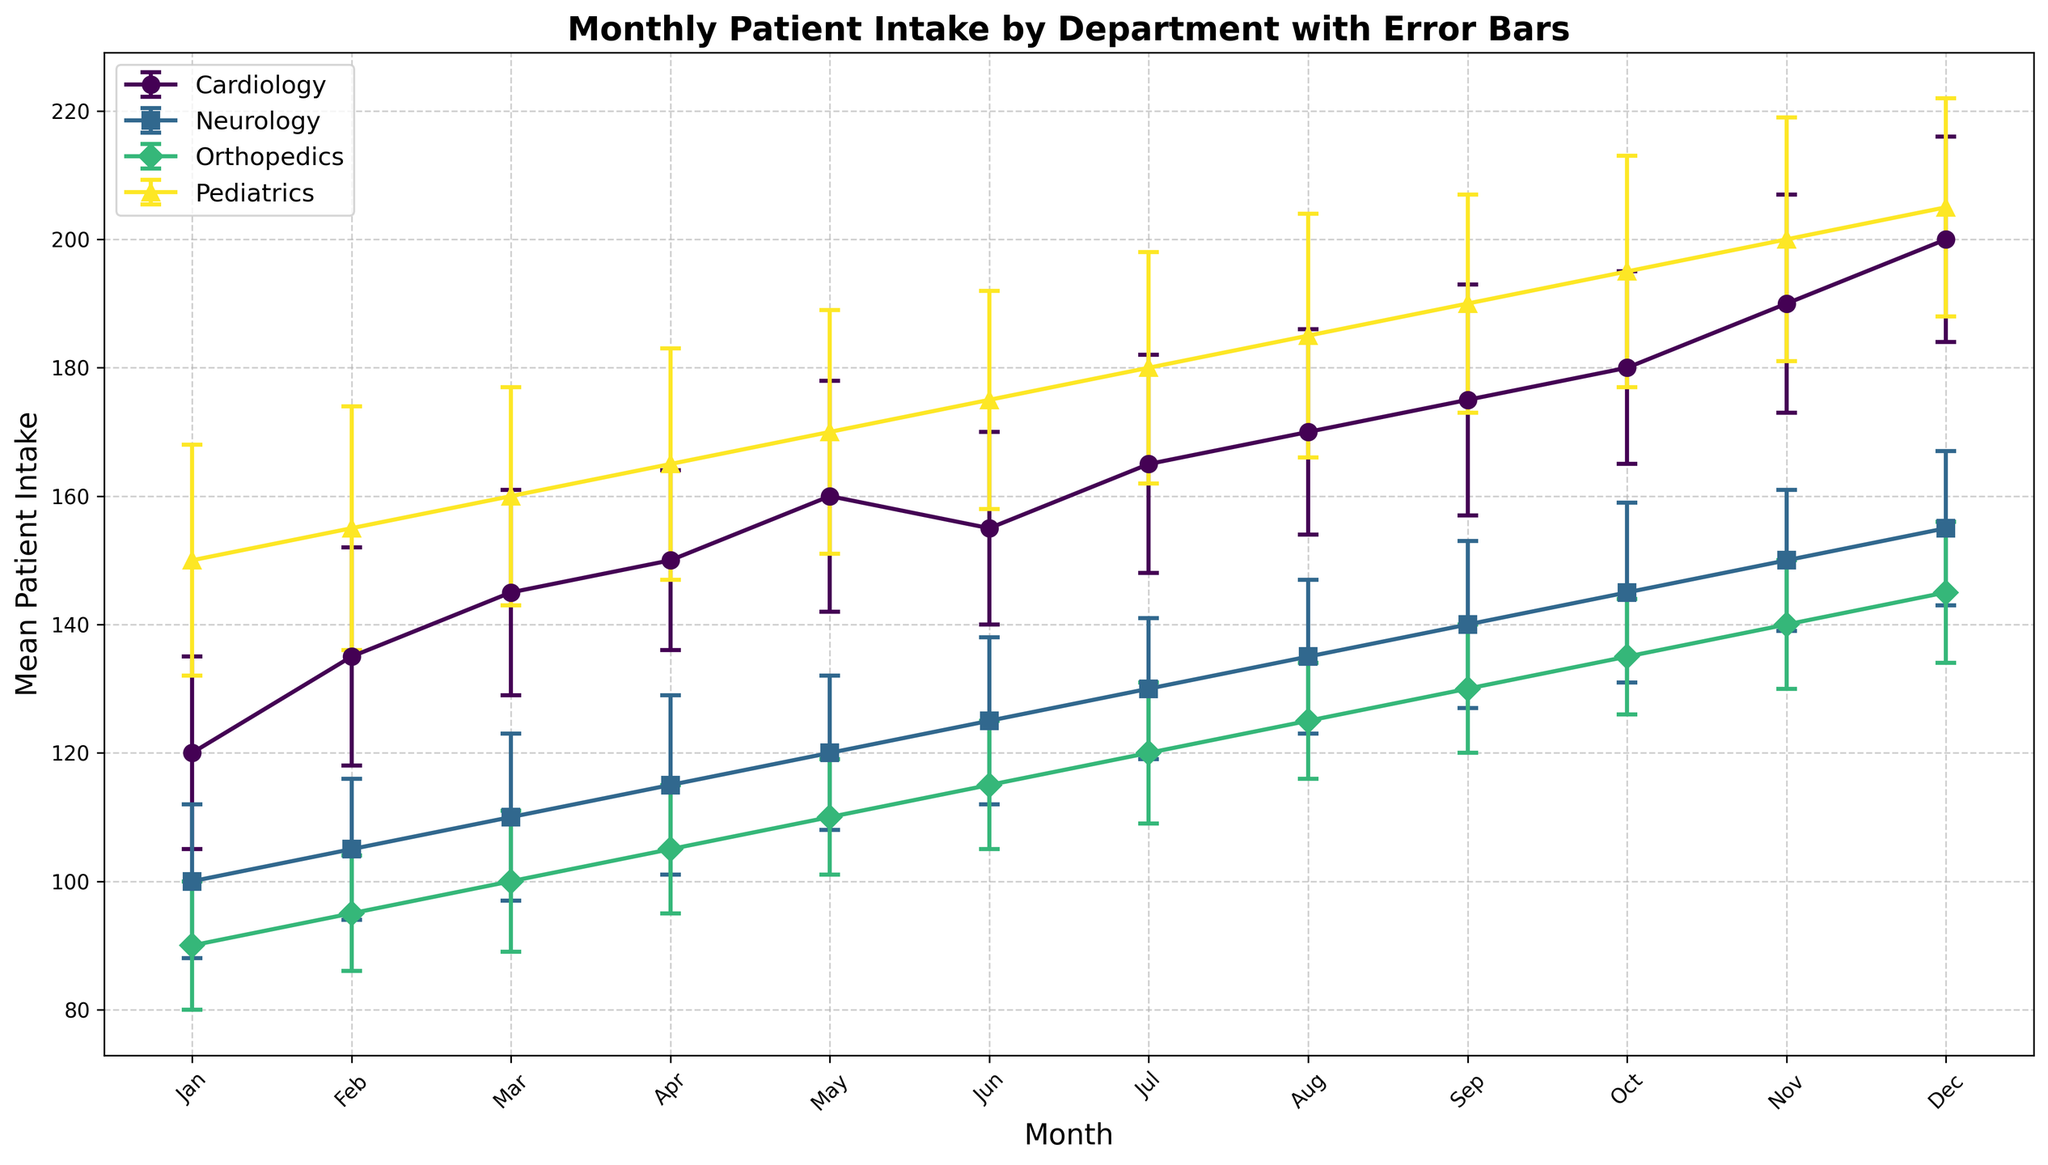What is the mean patient intake for Cardiology in June? The line for Cardiology shows the marker at June at a vertical position around 155, matching the table value.
Answer: 155 Which department had the highest mean patient intake in December? Review the December values on the plot. Pediatrics has the highest marker position, around 205.
Answer: Pediatrics What is the average mean patient intake for Neurology across all months? Sum the means for Neurology and divide by 12: (100+105+110+115+120+125+130+135+140+145+150+155)/12 = 126.25
Answer: 126.25 Which two departments had the closest mean patient intake in April, and what are their values? Compare April markers for each department. Orthopedics (105) and Neurology (115) are closest.
Answer: Orthopedics (105) and Neurology (115) How much higher is the mean patient intake for Pediatrics in March compared to Orthopedics in March? Look at March values for Pediatrics (160) and Orthopedics (100), then subtract: 160 - 100 = 60
Answer: 60 Which department tends to have the highest variability in patient intake? Examine error bars for all departments; Pediatrics consistently has the largest error bars.
Answer: Pediatrics How does the mean patient intake change from January to December for Neurology? Check the markers for Neurology from January (100) to December (155): December mean is higher by 55.
Answer: Increases by 55 What is the total mean patient intake across all departments for October? Sum October values: Cardiology (180) + Neurology (145) + Orthopedics (135) + Pediatrics (195) = 655
Answer: 655 Which department shows the most consistent patient intake across the year based on the standard deviation? Identify the smallest error bars throughout; Orthopedics has consistently smaller error bars.
Answer: Orthopedics Is there any month where all departments have increasing mean patient intake from the previous month? Compare monthly increments for each department. From April to May, all show an increase.
Answer: Yes, April to May 